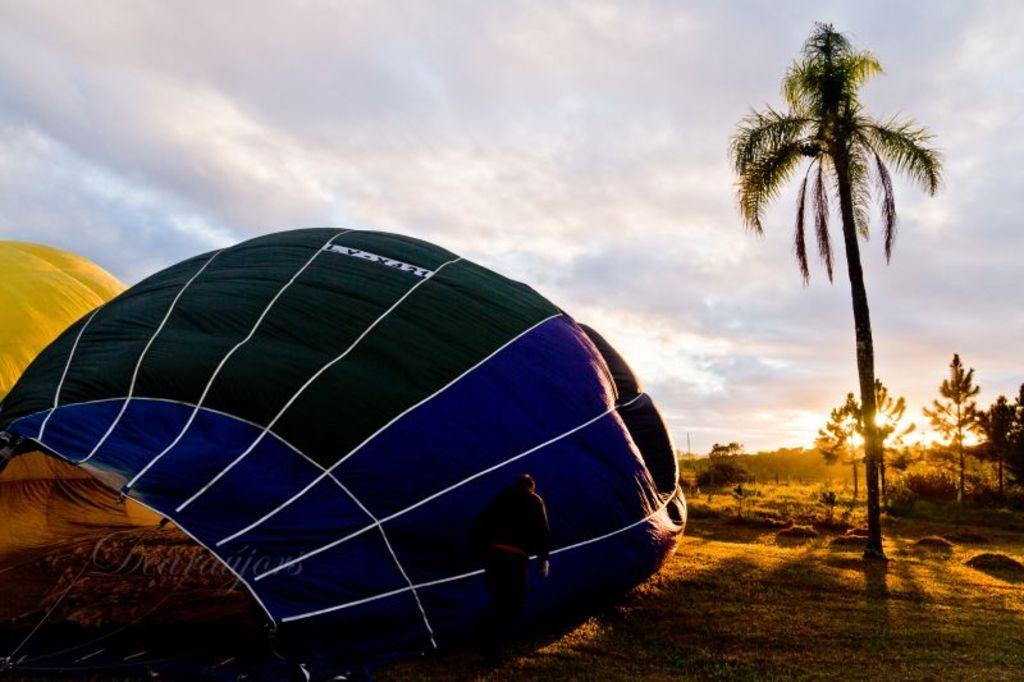What is the main object in the picture? There is a parachute in the picture. Who or what is associated with the parachute? There is a person in the picture. What is the ground like in the picture? The ground is visible in the picture, and it appears to have grass and plants. What can be seen in the sky in the picture? The sky is visible in the picture, and there are clouds and the sun present. What role does the person's uncle play in the picture? There is no mention of an uncle in the picture, so it is not possible to determine any role they might play. 